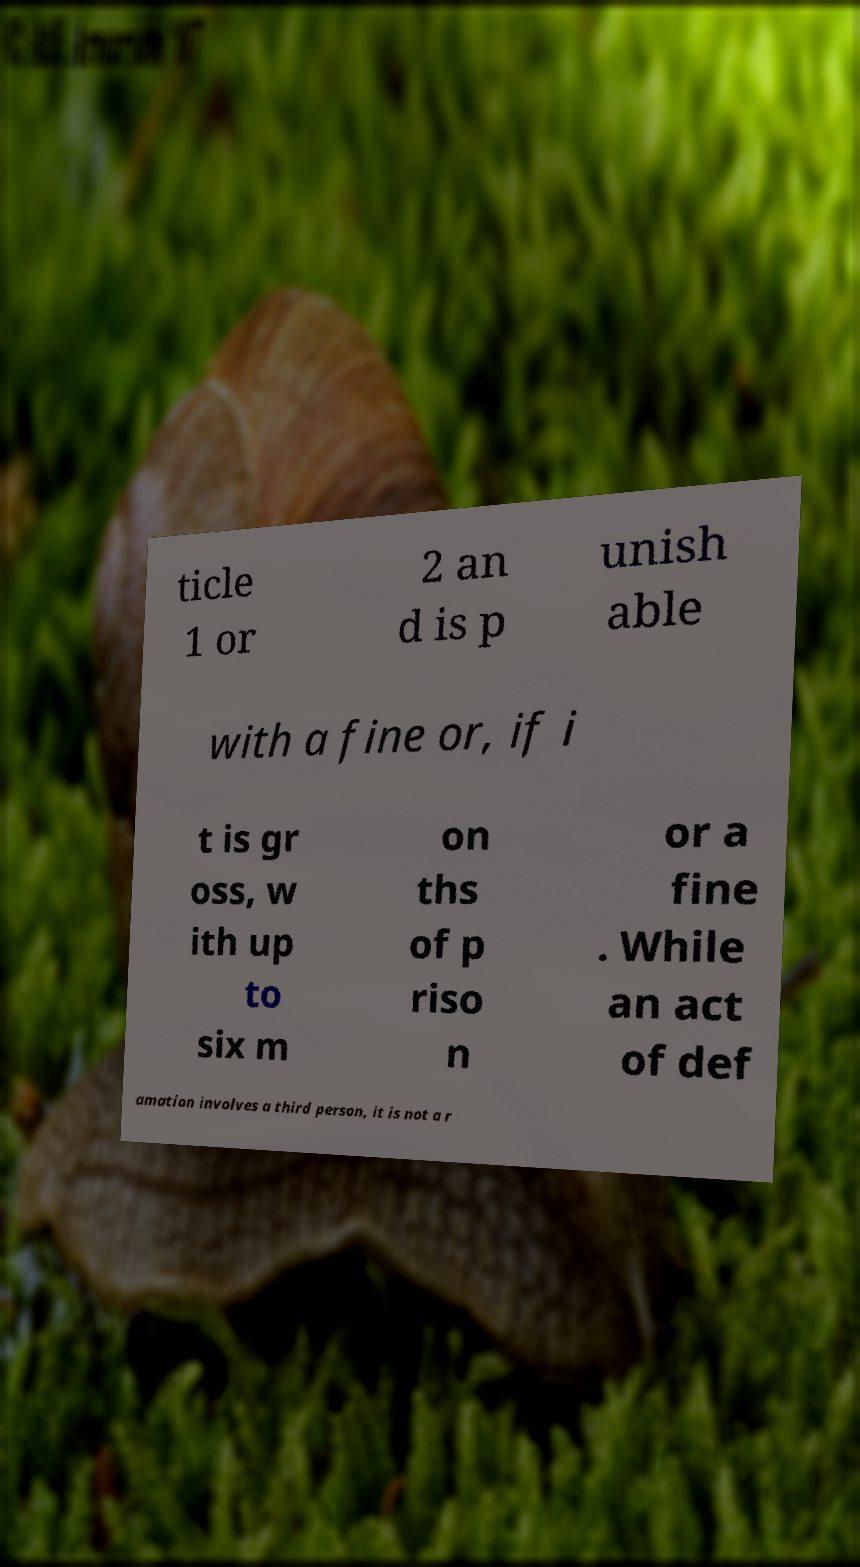Could you assist in decoding the text presented in this image and type it out clearly? ticle 1 or 2 an d is p unish able with a fine or, if i t is gr oss, w ith up to six m on ths of p riso n or a fine . While an act of def amation involves a third person, it is not a r 